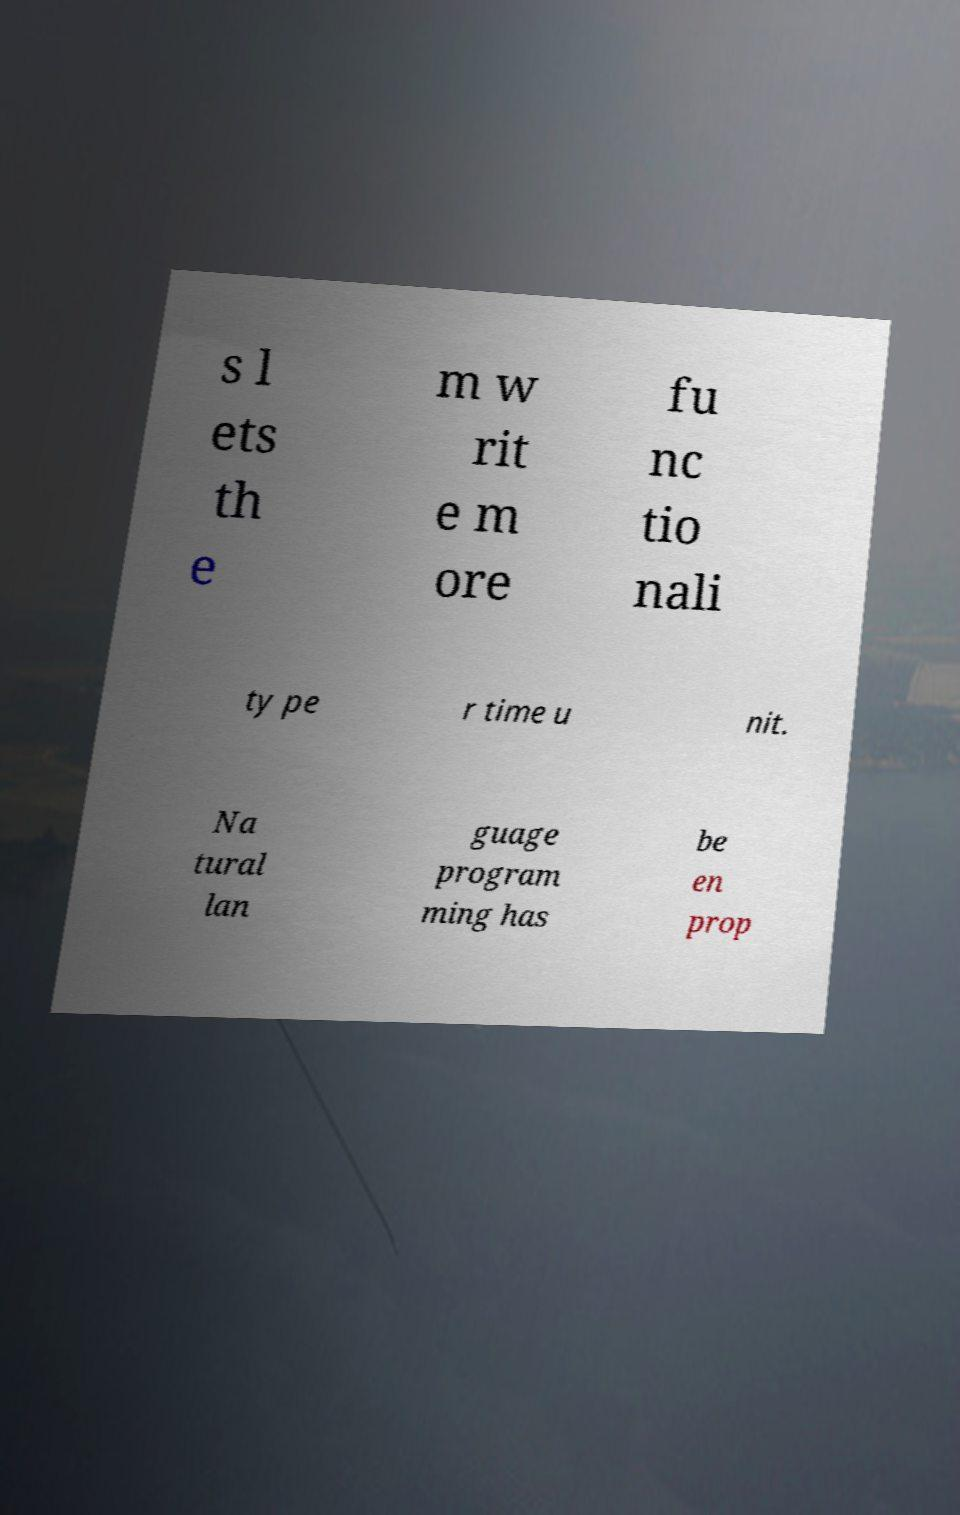What messages or text are displayed in this image? I need them in a readable, typed format. s l ets th e m w rit e m ore fu nc tio nali ty pe r time u nit. Na tural lan guage program ming has be en prop 